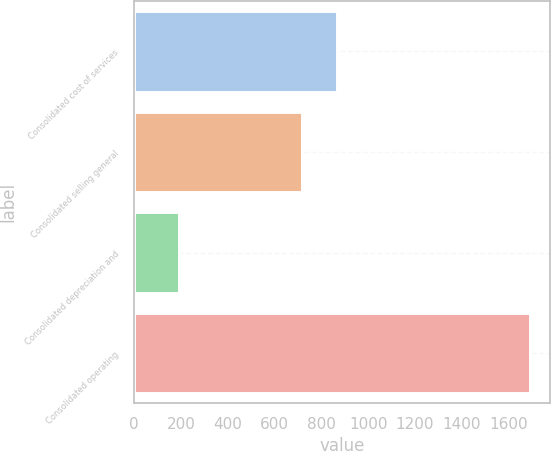<chart> <loc_0><loc_0><loc_500><loc_500><bar_chart><fcel>Consolidated cost of services<fcel>Consolidated selling general<fcel>Consolidated depreciation and<fcel>Consolidated operating<nl><fcel>866.11<fcel>715.8<fcel>189.6<fcel>1692.7<nl></chart> 